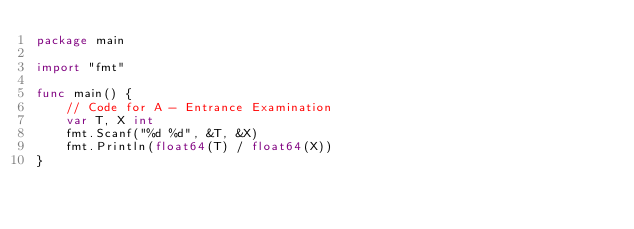<code> <loc_0><loc_0><loc_500><loc_500><_Go_>package main

import "fmt"

func main() {
	// Code for A - Entrance Examination
	var T, X int
	fmt.Scanf("%d %d", &T, &X)
	fmt.Println(float64(T) / float64(X))
}
</code> 